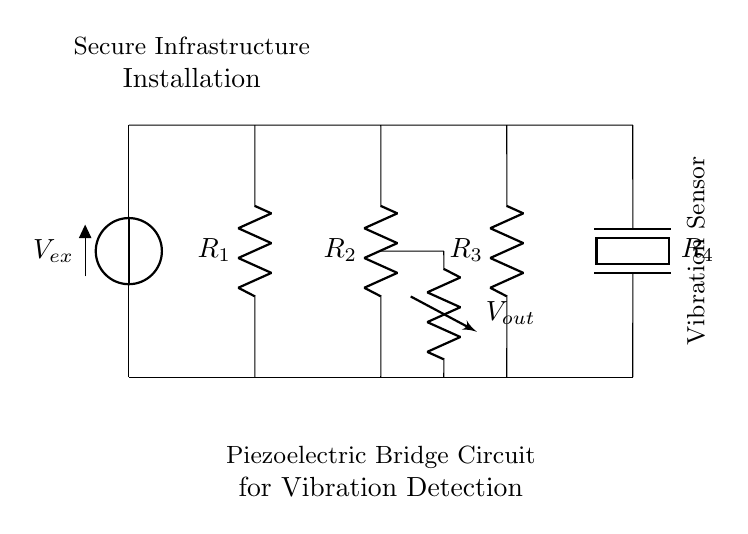What type of circuit is this? This circuit is a bridge circuit specifically designed for vibration detection using piezoelectric elements. Bridge circuits typically consist of multiple resistive components arranged to measure changes in resistance, particularly due to mechanical stress or vibration in this case.
Answer: bridge circuit What components are used in this circuit? The circuit contains a voltage source, four resistors, and a piezoelectric element. Each of these components has a specific role, with the piezoelectric component being key for detecting vibrations, while the resistors help balance the bridge and determine the output voltage.
Answer: voltage source, resistors, piezoelectric element How many resistors are in the circuit? There are three resistors (R1, R2, R3) and one piezoelectric resistor (R4) in the circuit, making a total of four resistive components. This total includes the piezoelectric element functioning as a resistor in this context, essential for the bridge's operation.
Answer: four What is the output voltage denoted in the circuit? The output voltage is marked as Vout, which is located at the junction of two resistors in the bridge. This output voltage will vary based on the vibrations detected by the piezoelectric element, changing the resistance and hence the node voltage output.
Answer: Vout What is the purpose of the piezoelectric element in this circuit? The piezoelectric element serves as a vibration sensor, converting mechanical stress from vibrations into an electrical signal, which changes the resistance in the bridge circuit. This change is what ultimately provides an output that can indicate the levels of vibrations affecting a secure installation.
Answer: vibration sensor What does the notation Vex indicate in the circuit? Vex indicates the excitation voltage supplied to the bridge circuit, which drives the circuit to measure the changes in resistance caused by vibrations. This voltage is crucial for ensuring that the piezoelectric sensor function can be efficiently monitored.
Answer: excitation voltage 